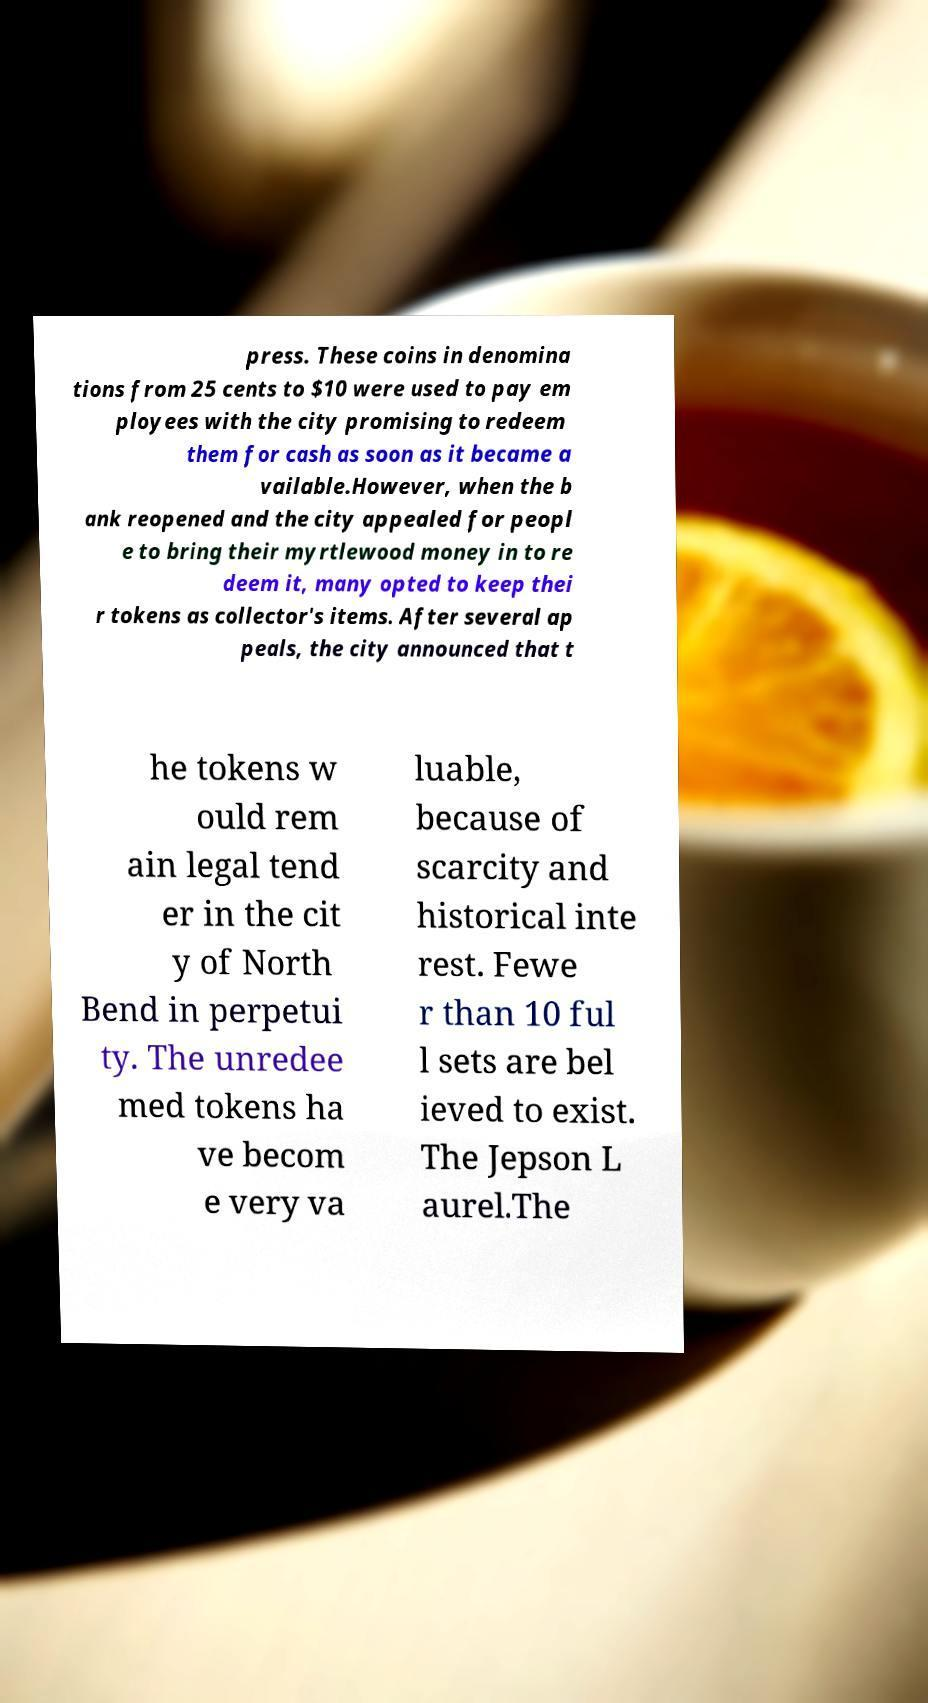Could you assist in decoding the text presented in this image and type it out clearly? press. These coins in denomina tions from 25 cents to $10 were used to pay em ployees with the city promising to redeem them for cash as soon as it became a vailable.However, when the b ank reopened and the city appealed for peopl e to bring their myrtlewood money in to re deem it, many opted to keep thei r tokens as collector's items. After several ap peals, the city announced that t he tokens w ould rem ain legal tend er in the cit y of North Bend in perpetui ty. The unredee med tokens ha ve becom e very va luable, because of scarcity and historical inte rest. Fewe r than 10 ful l sets are bel ieved to exist. The Jepson L aurel.The 